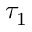<formula> <loc_0><loc_0><loc_500><loc_500>\tau _ { 1 }</formula> 